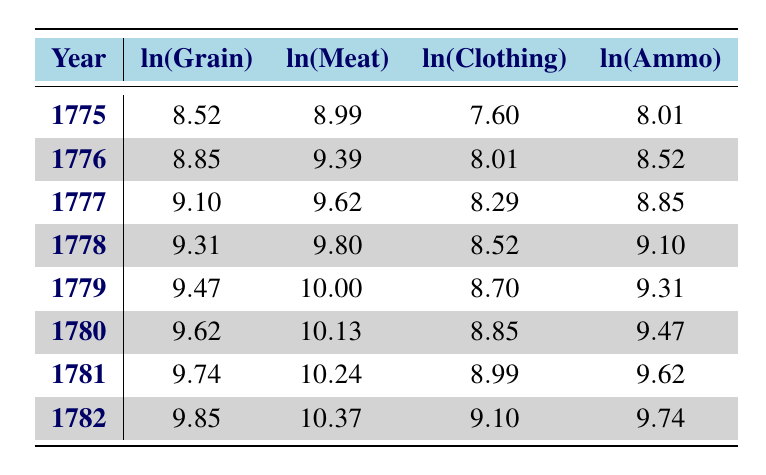What was the cost of grain in 1780? Looking at the table, the cost of grain for the year 1780 is recorded as 15000.
Answer: 15000 What is the log value for clothing cost in 1777? Referring to the table, the natural logarithm of clothing costs for the year 1777 is indicated as 8.29.
Answer: 8.29 In which year did the ammunition cost first exceed 10000? By examining the ammunition costs across the years, we see it first exceeds 10000 in 1780, where it is 13000.
Answer: 1780 What was the total cost of all supplies (grain, meat, clothing, and ammunition) for the year 1779? To find the total cost for 1779, we sum the costs: 13000 (Grain) + 22000 (Meat) + 6000 (Clothing) + 11000 (Ammunition) = 62000.
Answer: 62000 Was the cost of meat higher in 1776 than in 1775? Looking at the table, the meat cost for 1775 is 8000 and for 1776 it is 12000. Since 12000 is greater than 8000, the statement is true.
Answer: Yes What is the percentage increase of grain cost from 1775 to 1782? The grain cost in 1775 is 5000 and in 1782 is 19000. The increase is 19000 - 5000 = 14000. The percentage increase is (14000/5000) * 100 = 280%.
Answer: 280% Which year had the highest recorded cost for clothing? Observing the clothing costs in the table, the highest cost recorded is 9000 in the year 1782.
Answer: 1782 What is the average cost of ammunition from 1775 to 1782? To calculate the average ammunition cost: (3000 + 5000 + 7000 + 9000 + 11000 + 13000 + 15000 + 17000) = 65000; dividing by 8 years gives 65000/8 = 8125.
Answer: 8125 Is the cost of grain in 1781 higher than the cost of meat in 1775? The grain cost in 1781 is 17000 and the meat cost in 1775 is 8000. Since 17000 is greater than 8000, the statement is true.
Answer: Yes 